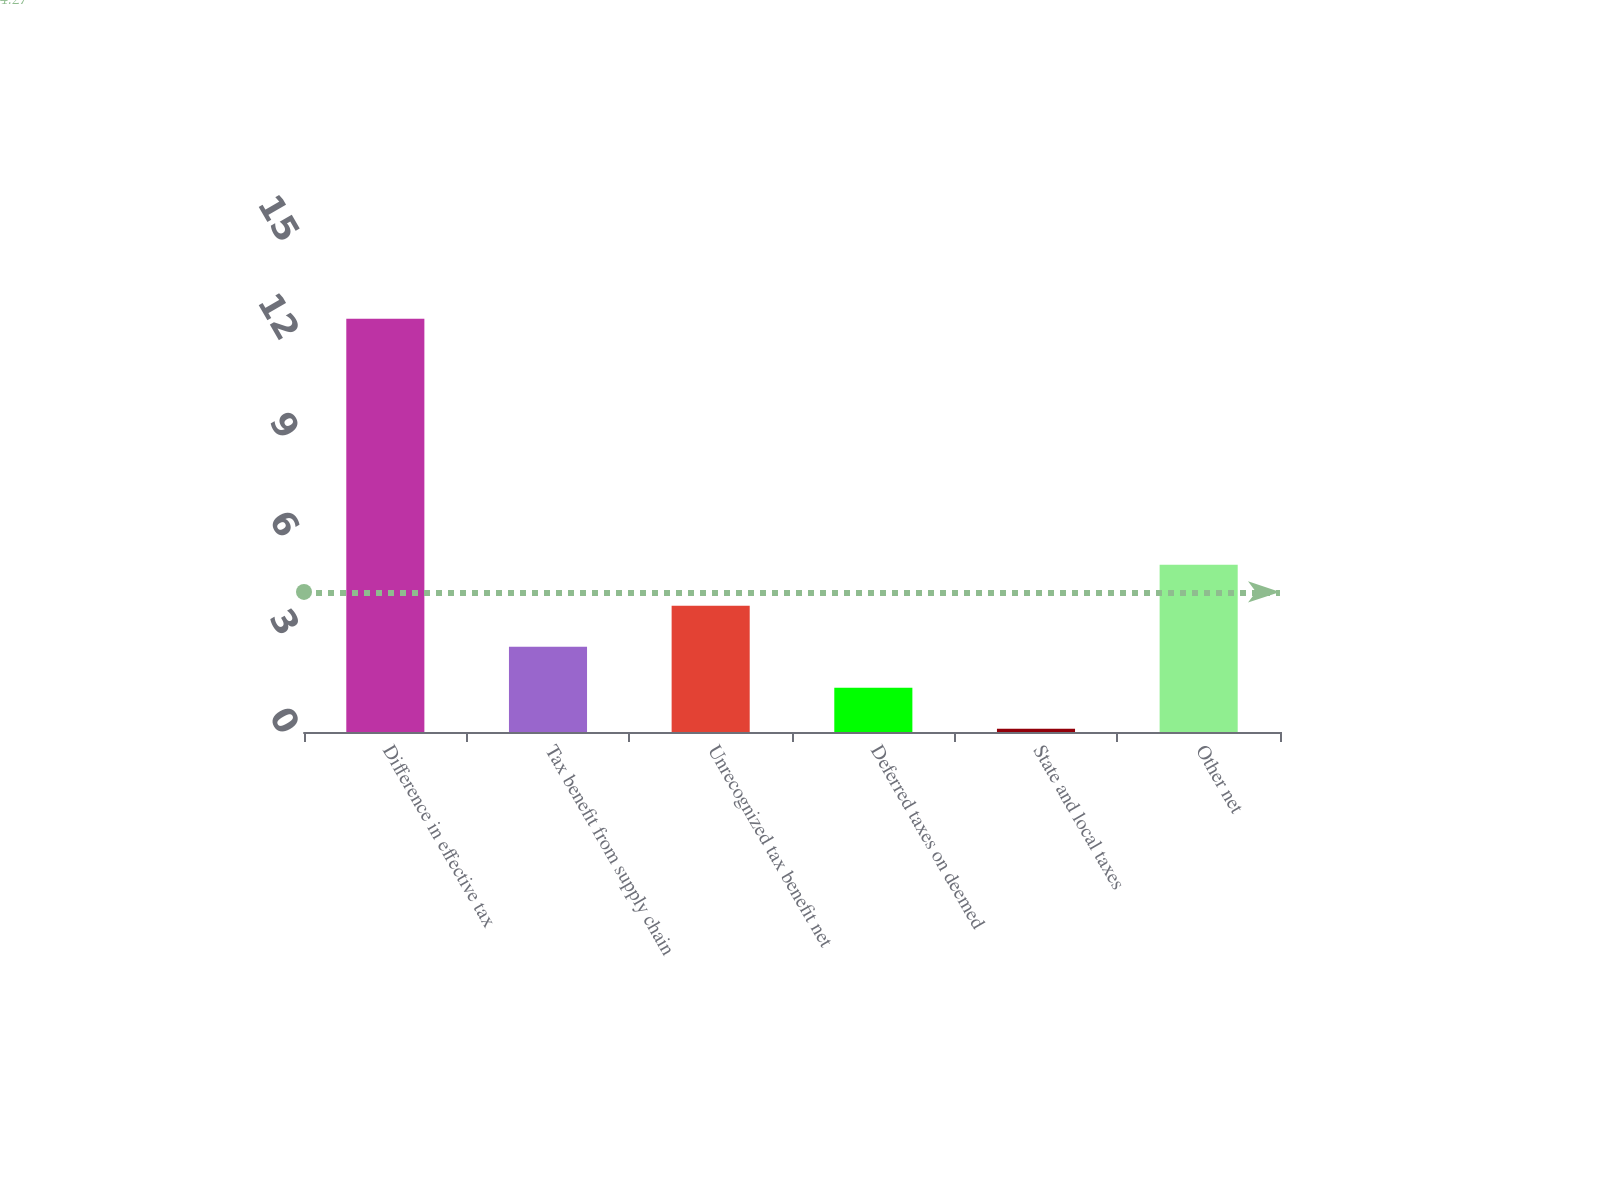<chart> <loc_0><loc_0><loc_500><loc_500><bar_chart><fcel>Difference in effective tax<fcel>Tax benefit from supply chain<fcel>Unrecognized tax benefit net<fcel>Deferred taxes on deemed<fcel>State and local taxes<fcel>Other net<nl><fcel>12.6<fcel>2.6<fcel>3.85<fcel>1.35<fcel>0.1<fcel>5.1<nl></chart> 